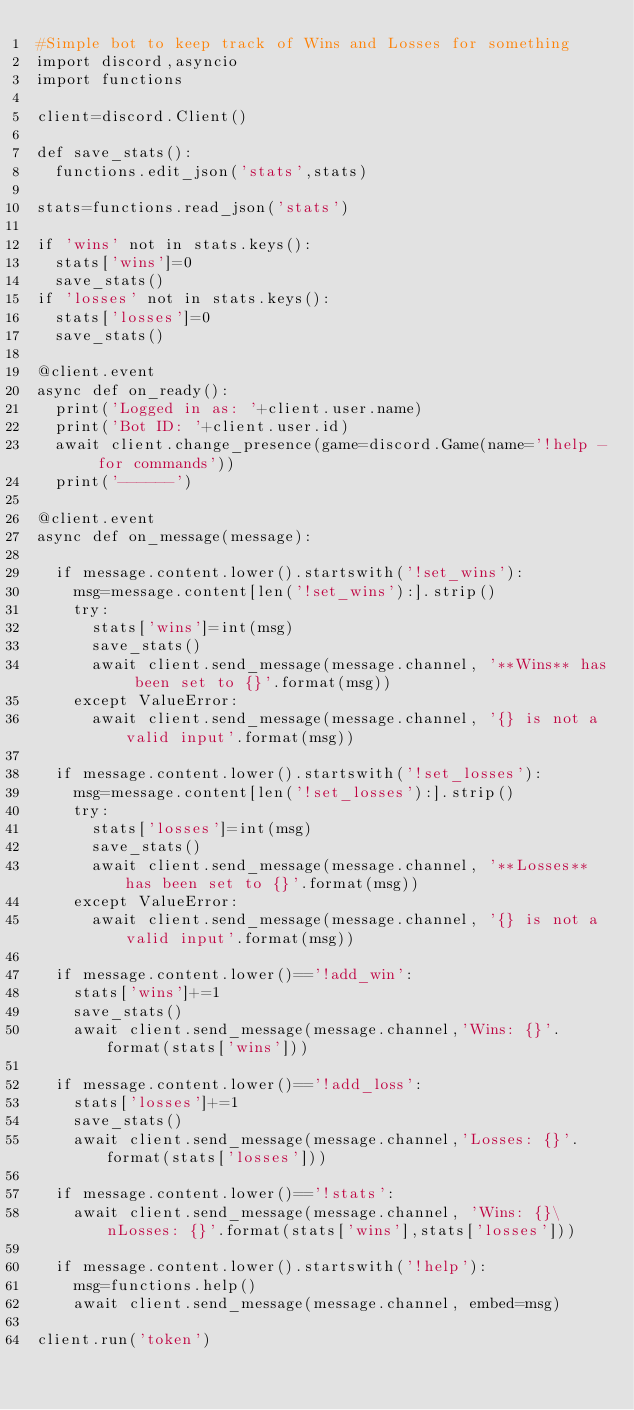Convert code to text. <code><loc_0><loc_0><loc_500><loc_500><_Python_>#Simple bot to keep track of Wins and Losses for something
import discord,asyncio
import functions

client=discord.Client()

def save_stats():
	functions.edit_json('stats',stats)

stats=functions.read_json('stats')

if 'wins' not in stats.keys():
	stats['wins']=0
	save_stats()
if 'losses' not in stats.keys():
	stats['losses']=0
	save_stats()

@client.event
async def on_ready():
	print('Logged in as: '+client.user.name)
	print('Bot ID: '+client.user.id)
	await client.change_presence(game=discord.Game(name='!help - for commands'))
	print('------')

@client.event
async def on_message(message):

	if message.content.lower().startswith('!set_wins'):
		msg=message.content[len('!set_wins'):].strip()
		try:
			stats['wins']=int(msg)
			save_stats()
			await client.send_message(message.channel, '**Wins** has been set to {}'.format(msg))
		except ValueError:
			await client.send_message(message.channel, '{} is not a valid input'.format(msg))

	if message.content.lower().startswith('!set_losses'):
		msg=message.content[len('!set_losses'):].strip()
		try:
			stats['losses']=int(msg)
			save_stats()
			await client.send_message(message.channel, '**Losses** has been set to {}'.format(msg))
		except ValueError:
			await client.send_message(message.channel, '{} is not a valid input'.format(msg))

	if message.content.lower()=='!add_win':
		stats['wins']+=1
		save_stats()
		await client.send_message(message.channel,'Wins: {}'.format(stats['wins']))

	if message.content.lower()=='!add_loss':
		stats['losses']+=1
		save_stats()
		await client.send_message(message.channel,'Losses: {}'.format(stats['losses']))

	if message.content.lower()=='!stats':
		await client.send_message(message.channel, 'Wins: {}\nLosses: {}'.format(stats['wins'],stats['losses']))

	if message.content.lower().startswith('!help'):
		msg=functions.help()
		await client.send_message(message.channel, embed=msg)

client.run('token')
</code> 